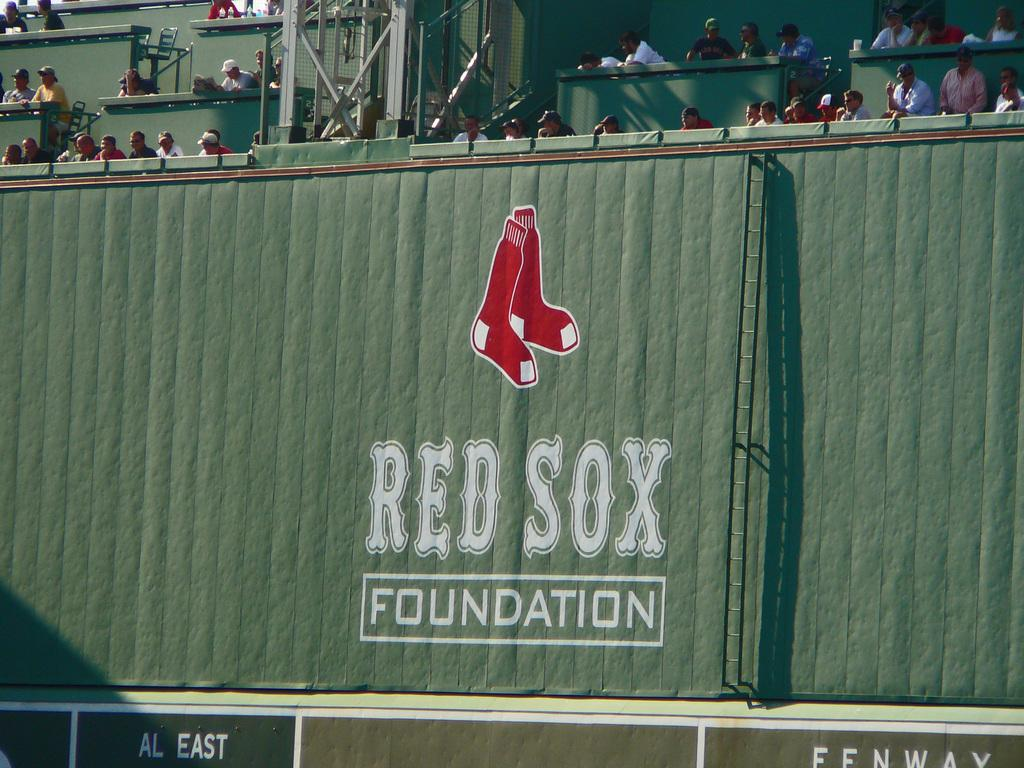<image>
Offer a succinct explanation of the picture presented. A few people are high in the stands above a banner for the Red Sox Foundation. 